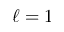<formula> <loc_0><loc_0><loc_500><loc_500>\ell = 1</formula> 